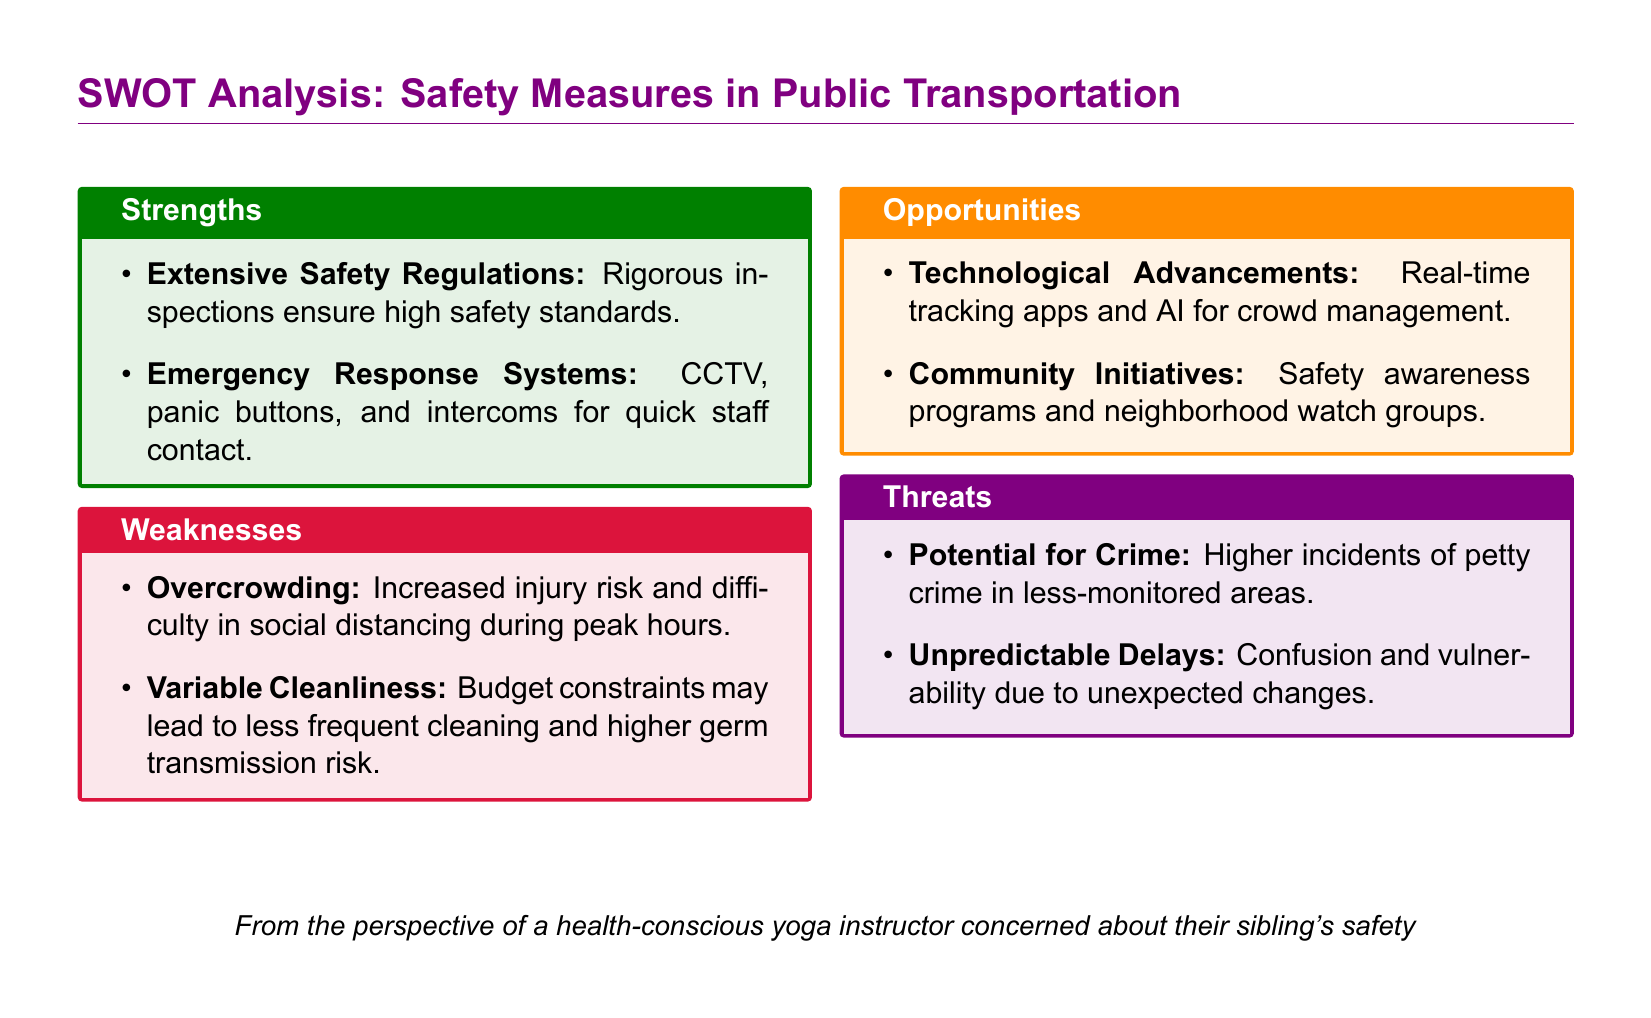what is one strength of public transportation safety measures? The document lists "Extensive Safety Regulations" as a strength, indicating rigorous inspections ensure high safety standards.
Answer: Extensive Safety Regulations what is one weakness associated with public transportation safety? The document mentions "Overcrowding" as a weakness, which increases the risk of injury and complicates social distancing.
Answer: Overcrowding what technological advancement is mentioned in the opportunities section? The document references "Real-time tracking apps" as a technological advancement that could improve safety in public transportation.
Answer: Real-time tracking apps what is a potential threat identified in the analysis? The document states "Potential for Crime" as a threat, indicating higher incidents of petty crime in less-monitored areas.
Answer: Potential for Crime how many strengths are listed in the SWOT analysis? The document lists two strengths in the strengths section of the analysis.
Answer: 2 which section of the SWOT analysis discusses community initiatives? The "Opportunities" section mentions "Community Initiatives" as a way to improve public transportation safety.
Answer: Opportunities what system is in place for emergency responses according to the strengths? The document mentions "Emergency Response Systems," highlighting the presence of CCTV, panic buttons, and intercoms for quick staff contact.
Answer: Emergency Response Systems what is the color associated with threats in the SWOT analysis? The document attributes the color "yogapurple" to the threats section of the analysis.
Answer: yogapurple what does the SWOT analysis emphasize for family members of public transportation users? The analysis emphasizes safety measures in public transportation, indicating potential risks and the importance of vigilance.
Answer: safety measures 